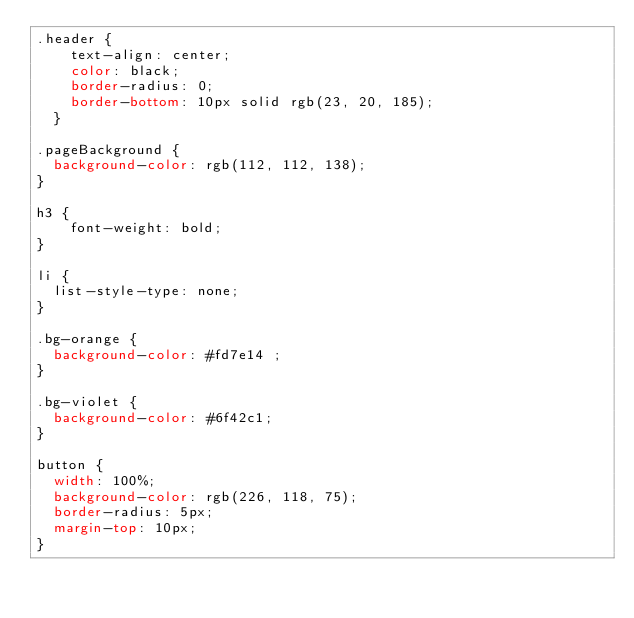<code> <loc_0><loc_0><loc_500><loc_500><_CSS_>.header {
    text-align: center;
    color: black;
    border-radius: 0;
    border-bottom: 10px solid rgb(23, 20, 185);
  }
  
.pageBackground {
  background-color: rgb(112, 112, 138);
}

h3 {
    font-weight: bold;
}

li {
  list-style-type: none;
}

.bg-orange {
  background-color: #fd7e14 ;
}

.bg-violet {
  background-color: #6f42c1;
}

button {
  width: 100%;
  background-color: rgb(226, 118, 75);
  border-radius: 5px;
  margin-top: 10px;
}

</code> 